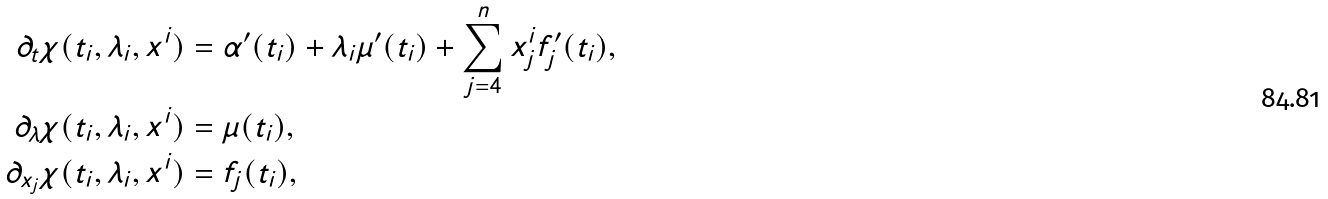Convert formula to latex. <formula><loc_0><loc_0><loc_500><loc_500>\partial _ { t } \chi ( t _ { i } , \lambda _ { i } , x ^ { i } ) & = \alpha ^ { \prime } ( t _ { i } ) + \lambda _ { i } \mu ^ { \prime } ( t _ { i } ) + \sum _ { j = 4 } ^ { n } x _ { j } ^ { i } f _ { j } ^ { \prime } ( t _ { i } ) , \\ \partial _ { \lambda } \chi ( t _ { i } , \lambda _ { i } , x ^ { i } ) & = \mu ( t _ { i } ) , \\ \partial _ { x _ { j } } \chi ( t _ { i } , \lambda _ { i } , x ^ { i } ) & = f _ { j } ( t _ { i } ) ,</formula> 